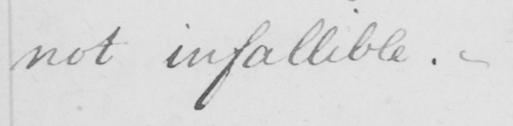Can you tell me what this handwritten text says? not infallible .  _ 